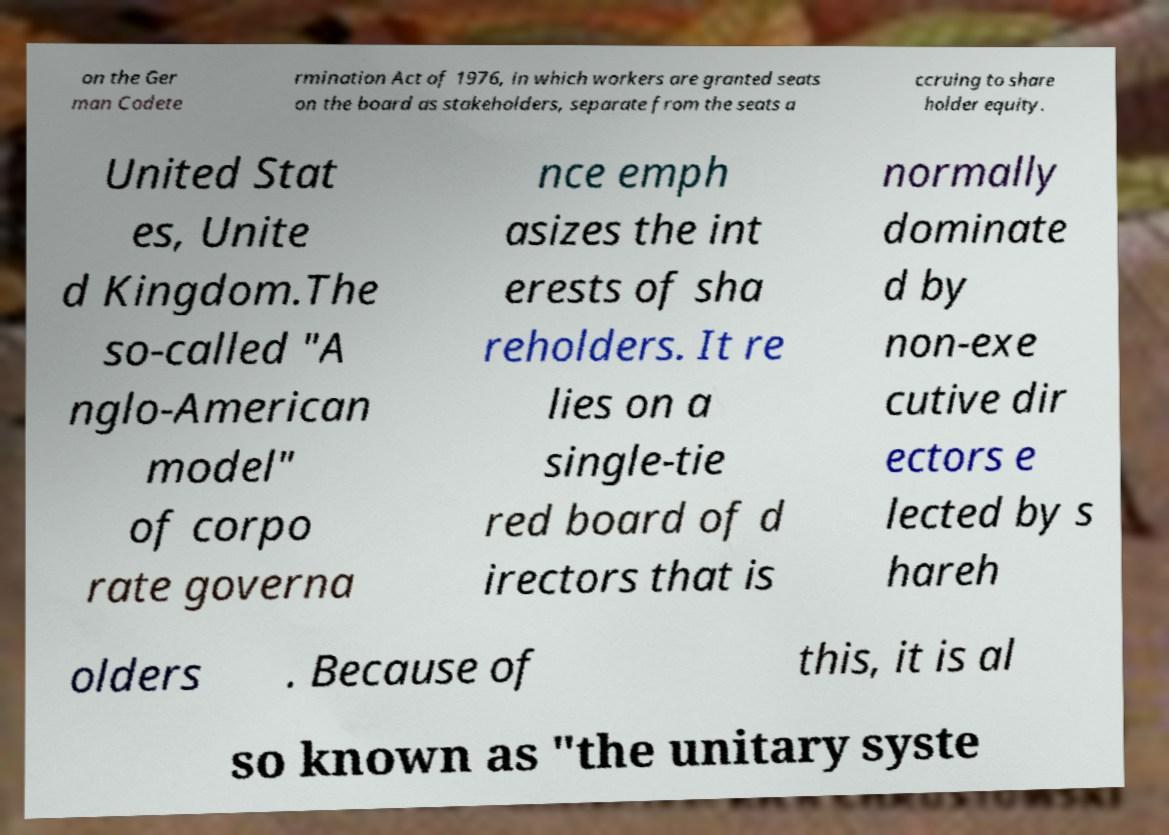Could you assist in decoding the text presented in this image and type it out clearly? on the Ger man Codete rmination Act of 1976, in which workers are granted seats on the board as stakeholders, separate from the seats a ccruing to share holder equity. United Stat es, Unite d Kingdom.The so-called "A nglo-American model" of corpo rate governa nce emph asizes the int erests of sha reholders. It re lies on a single-tie red board of d irectors that is normally dominate d by non-exe cutive dir ectors e lected by s hareh olders . Because of this, it is al so known as "the unitary syste 